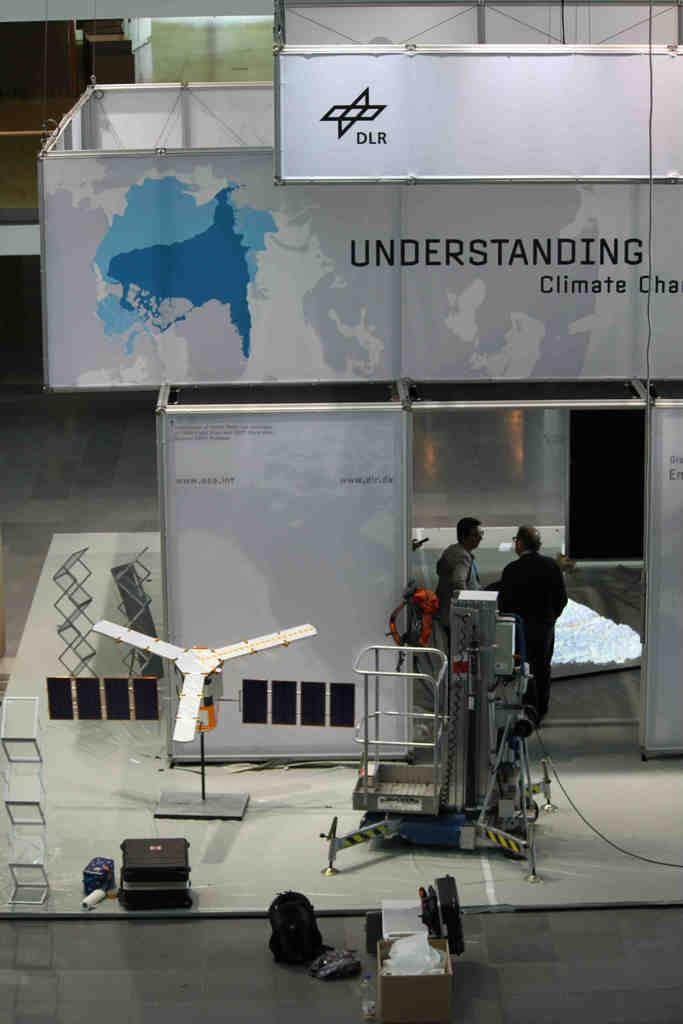How many people are in the image? There are two persons standing in the image. What else can be seen in the image besides the people? There are machines, a building, bags, and other unspecified objects on the floor in the image. What is written on the building? Unfortunately, the specific text written on the building cannot be determined from the image. What might the bags on the floor be used for? The bags on the floor might be used for carrying or storing items. What type of wax can be seen melting on the yard in the image? There is no wax or yard present in the image; it features two people, machines, a building, bags, and other unspecified objects on the floor. 